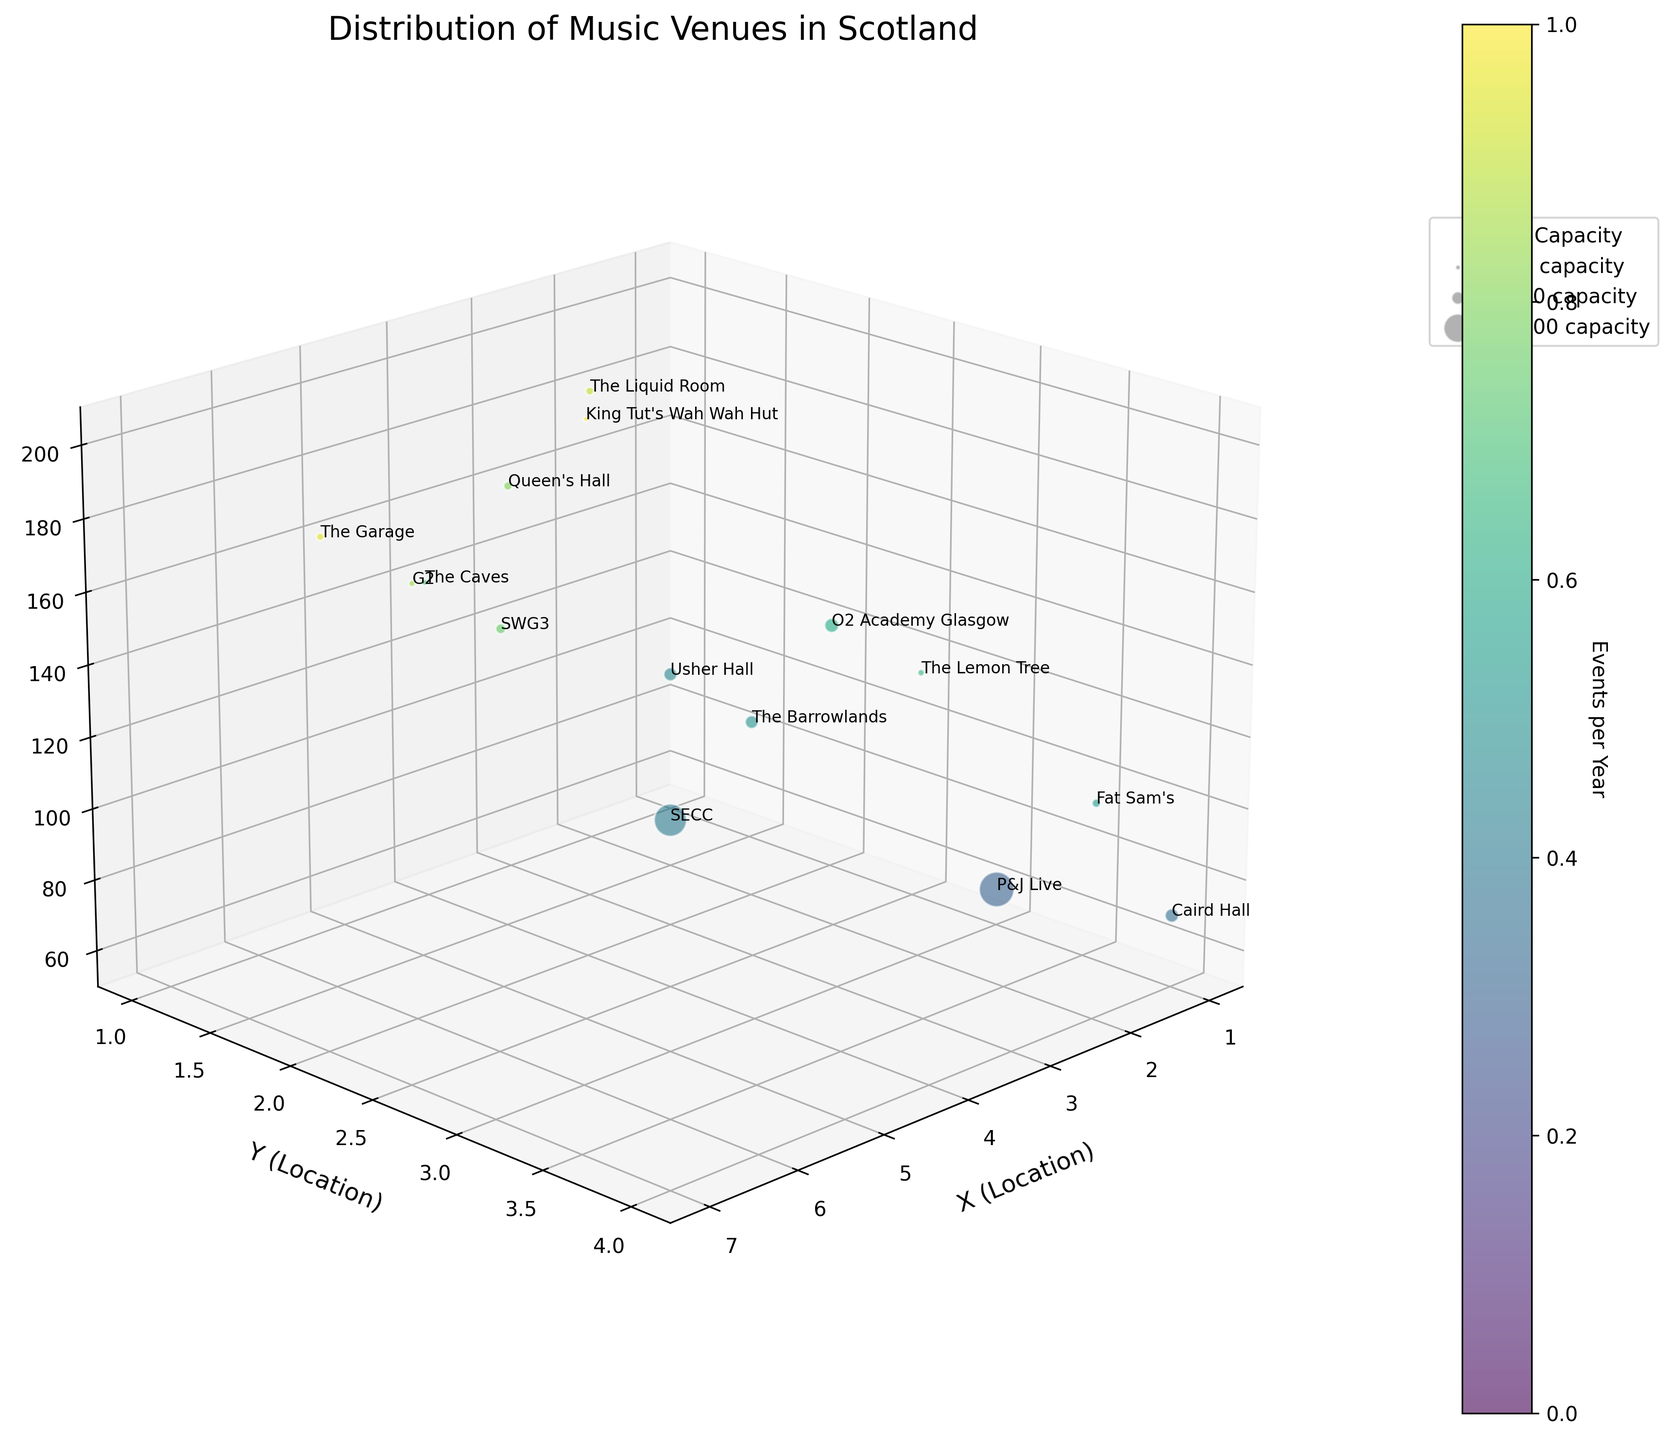What is the title of the figure? The title is usually found at the top of the figure. In this case, it reads "Distribution of Music Venues in Scotland".
Answer: Distribution of Music Venues in Scotland How many venues are represented in the figure? By counting the number of unique data points or bubbles in the plot, we can determine the number of venues. Each bubble represents a different venue.
Answer: 14 Which venue has the highest frequency of events per year? To find this, identify the bubble positioned highest on the Z-axis (Events per Year). The highest position corresponds to King Tut's Wah Wah Hut with 200 events per year.
Answer: King Tut's Wah Wah Hut What is the range of venue capacities represented in the figure? Look at the scale of bubble sizes. The smallest bubble's capacity is 300 (King Tut's Wah Wah Hut), and the largest is 15,000 (P&J Live). Subtracting these gives us the range.
Answer: 14,700 Which city hosts the most number of music venues according to the figure? Observe the distribution on the X and Y axis. The majority of bubbles are clustered around a single location point designated for Glasgow, indicating it has the most venues.
Answer: Glasgow Do Glasgow venues generally have a higher frequency of events compared to Edinburgh venues? Compare the positions on the Z-axis for venues in both cities. Glasgow venues like King Tut's Wah Wah Hut and G2 are high on the Z-axis, while Edinburgh venues have moderately high values like The Liquid Room with 180 events per year.
Answer: Yes Which venue in Aberdeen has the highest capacity? Compare the bubble sizes in the Aberdeen (Y=3) cluster. The largest bubble represents P&J Live, which has a capacity of 15,000.
Answer: P&J Live Are there more venues with capacities greater than 1,000 or less than 1,000? Count the bubbles with capacities greater than 1,000 (larger bubbles) and those less than 1,000 (smaller bubbles). Summing these counts shows more venues with capacities under 1,000.
Answer: Less than 1,000 Which venue has the smallest capacity, and how many events does it host per year? Identify the smallest bubble and check its Z-axis position. King Tut's Wah Wah Hut has the smallest capacity (300) and hosts 200 events per year.
Answer: King Tut's Wah Wah Hut, 200 Which has a larger capacity: Venues in Edinburgh or Dundee? Sum the individual capacities of venues in both Edinburgh (Usher Hall, The Liquid Room, Queen's Hall, The Caves) and Dundee (Caird Hall, Fat Sam's). Edinburgh exceeds with 4,200 versus Dundee's 3,200.
Answer: Edinburgh 